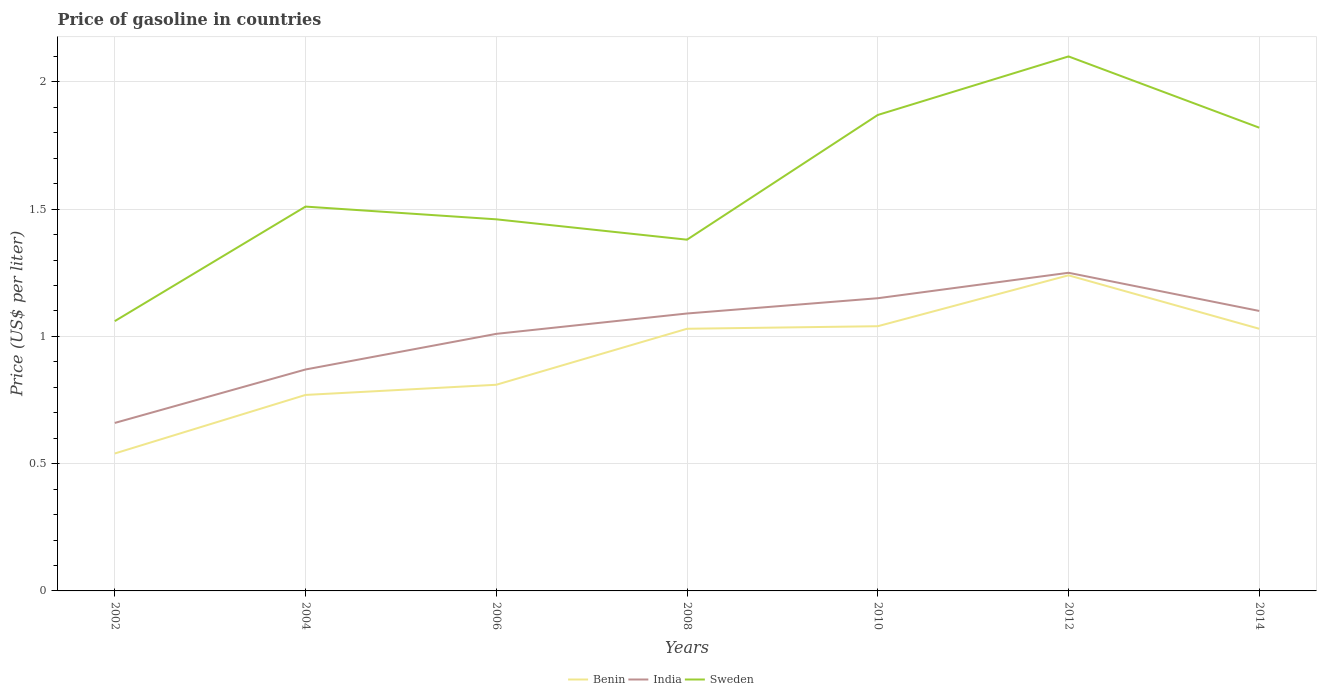How many different coloured lines are there?
Your response must be concise. 3. Is the number of lines equal to the number of legend labels?
Your answer should be very brief. Yes. Across all years, what is the maximum price of gasoline in Sweden?
Your answer should be compact. 1.06. What is the total price of gasoline in India in the graph?
Offer a very short reply. -0.38. What is the difference between the highest and the lowest price of gasoline in Sweden?
Make the answer very short. 3. How many lines are there?
Make the answer very short. 3. How many years are there in the graph?
Keep it short and to the point. 7. What is the difference between two consecutive major ticks on the Y-axis?
Ensure brevity in your answer.  0.5. Does the graph contain any zero values?
Keep it short and to the point. No. Where does the legend appear in the graph?
Your answer should be compact. Bottom center. How many legend labels are there?
Give a very brief answer. 3. How are the legend labels stacked?
Give a very brief answer. Horizontal. What is the title of the graph?
Your answer should be compact. Price of gasoline in countries. Does "Guinea" appear as one of the legend labels in the graph?
Give a very brief answer. No. What is the label or title of the X-axis?
Ensure brevity in your answer.  Years. What is the label or title of the Y-axis?
Your answer should be compact. Price (US$ per liter). What is the Price (US$ per liter) of Benin in 2002?
Offer a terse response. 0.54. What is the Price (US$ per liter) in India in 2002?
Make the answer very short. 0.66. What is the Price (US$ per liter) in Sweden in 2002?
Make the answer very short. 1.06. What is the Price (US$ per liter) of Benin in 2004?
Provide a short and direct response. 0.77. What is the Price (US$ per liter) in India in 2004?
Offer a very short reply. 0.87. What is the Price (US$ per liter) in Sweden in 2004?
Keep it short and to the point. 1.51. What is the Price (US$ per liter) of Benin in 2006?
Make the answer very short. 0.81. What is the Price (US$ per liter) of Sweden in 2006?
Keep it short and to the point. 1.46. What is the Price (US$ per liter) of India in 2008?
Keep it short and to the point. 1.09. What is the Price (US$ per liter) of Sweden in 2008?
Keep it short and to the point. 1.38. What is the Price (US$ per liter) in India in 2010?
Your response must be concise. 1.15. What is the Price (US$ per liter) in Sweden in 2010?
Keep it short and to the point. 1.87. What is the Price (US$ per liter) in Benin in 2012?
Your answer should be very brief. 1.24. What is the Price (US$ per liter) in India in 2012?
Make the answer very short. 1.25. What is the Price (US$ per liter) in India in 2014?
Give a very brief answer. 1.1. What is the Price (US$ per liter) in Sweden in 2014?
Give a very brief answer. 1.82. Across all years, what is the maximum Price (US$ per liter) in Benin?
Keep it short and to the point. 1.24. Across all years, what is the maximum Price (US$ per liter) in Sweden?
Provide a short and direct response. 2.1. Across all years, what is the minimum Price (US$ per liter) of Benin?
Keep it short and to the point. 0.54. Across all years, what is the minimum Price (US$ per liter) in India?
Keep it short and to the point. 0.66. Across all years, what is the minimum Price (US$ per liter) of Sweden?
Offer a terse response. 1.06. What is the total Price (US$ per liter) in Benin in the graph?
Your response must be concise. 6.46. What is the total Price (US$ per liter) of India in the graph?
Offer a very short reply. 7.13. What is the total Price (US$ per liter) in Sweden in the graph?
Your response must be concise. 11.2. What is the difference between the Price (US$ per liter) of Benin in 2002 and that in 2004?
Provide a succinct answer. -0.23. What is the difference between the Price (US$ per liter) of India in 2002 and that in 2004?
Your answer should be very brief. -0.21. What is the difference between the Price (US$ per liter) of Sweden in 2002 and that in 2004?
Your answer should be very brief. -0.45. What is the difference between the Price (US$ per liter) of Benin in 2002 and that in 2006?
Your answer should be very brief. -0.27. What is the difference between the Price (US$ per liter) in India in 2002 and that in 2006?
Give a very brief answer. -0.35. What is the difference between the Price (US$ per liter) in Benin in 2002 and that in 2008?
Provide a short and direct response. -0.49. What is the difference between the Price (US$ per liter) in India in 2002 and that in 2008?
Provide a succinct answer. -0.43. What is the difference between the Price (US$ per liter) in Sweden in 2002 and that in 2008?
Your answer should be very brief. -0.32. What is the difference between the Price (US$ per liter) in India in 2002 and that in 2010?
Offer a very short reply. -0.49. What is the difference between the Price (US$ per liter) in Sweden in 2002 and that in 2010?
Your answer should be compact. -0.81. What is the difference between the Price (US$ per liter) in Benin in 2002 and that in 2012?
Provide a short and direct response. -0.7. What is the difference between the Price (US$ per liter) in India in 2002 and that in 2012?
Make the answer very short. -0.59. What is the difference between the Price (US$ per liter) in Sweden in 2002 and that in 2012?
Provide a succinct answer. -1.04. What is the difference between the Price (US$ per liter) in Benin in 2002 and that in 2014?
Keep it short and to the point. -0.49. What is the difference between the Price (US$ per liter) of India in 2002 and that in 2014?
Your response must be concise. -0.44. What is the difference between the Price (US$ per liter) of Sweden in 2002 and that in 2014?
Ensure brevity in your answer.  -0.76. What is the difference between the Price (US$ per liter) of Benin in 2004 and that in 2006?
Keep it short and to the point. -0.04. What is the difference between the Price (US$ per liter) of India in 2004 and that in 2006?
Offer a very short reply. -0.14. What is the difference between the Price (US$ per liter) in Sweden in 2004 and that in 2006?
Keep it short and to the point. 0.05. What is the difference between the Price (US$ per liter) of Benin in 2004 and that in 2008?
Offer a terse response. -0.26. What is the difference between the Price (US$ per liter) of India in 2004 and that in 2008?
Provide a short and direct response. -0.22. What is the difference between the Price (US$ per liter) of Sweden in 2004 and that in 2008?
Your response must be concise. 0.13. What is the difference between the Price (US$ per liter) in Benin in 2004 and that in 2010?
Make the answer very short. -0.27. What is the difference between the Price (US$ per liter) in India in 2004 and that in 2010?
Your answer should be very brief. -0.28. What is the difference between the Price (US$ per liter) in Sweden in 2004 and that in 2010?
Provide a short and direct response. -0.36. What is the difference between the Price (US$ per liter) of Benin in 2004 and that in 2012?
Make the answer very short. -0.47. What is the difference between the Price (US$ per liter) of India in 2004 and that in 2012?
Offer a very short reply. -0.38. What is the difference between the Price (US$ per liter) of Sweden in 2004 and that in 2012?
Your answer should be compact. -0.59. What is the difference between the Price (US$ per liter) of Benin in 2004 and that in 2014?
Offer a terse response. -0.26. What is the difference between the Price (US$ per liter) in India in 2004 and that in 2014?
Keep it short and to the point. -0.23. What is the difference between the Price (US$ per liter) in Sweden in 2004 and that in 2014?
Your answer should be compact. -0.31. What is the difference between the Price (US$ per liter) in Benin in 2006 and that in 2008?
Provide a succinct answer. -0.22. What is the difference between the Price (US$ per liter) in India in 2006 and that in 2008?
Provide a succinct answer. -0.08. What is the difference between the Price (US$ per liter) in Sweden in 2006 and that in 2008?
Your answer should be compact. 0.08. What is the difference between the Price (US$ per liter) in Benin in 2006 and that in 2010?
Offer a very short reply. -0.23. What is the difference between the Price (US$ per liter) of India in 2006 and that in 2010?
Provide a short and direct response. -0.14. What is the difference between the Price (US$ per liter) in Sweden in 2006 and that in 2010?
Give a very brief answer. -0.41. What is the difference between the Price (US$ per liter) in Benin in 2006 and that in 2012?
Ensure brevity in your answer.  -0.43. What is the difference between the Price (US$ per liter) of India in 2006 and that in 2012?
Your answer should be compact. -0.24. What is the difference between the Price (US$ per liter) in Sweden in 2006 and that in 2012?
Offer a terse response. -0.64. What is the difference between the Price (US$ per liter) in Benin in 2006 and that in 2014?
Your answer should be very brief. -0.22. What is the difference between the Price (US$ per liter) in India in 2006 and that in 2014?
Offer a terse response. -0.09. What is the difference between the Price (US$ per liter) of Sweden in 2006 and that in 2014?
Your response must be concise. -0.36. What is the difference between the Price (US$ per liter) in Benin in 2008 and that in 2010?
Make the answer very short. -0.01. What is the difference between the Price (US$ per liter) of India in 2008 and that in 2010?
Your response must be concise. -0.06. What is the difference between the Price (US$ per liter) of Sweden in 2008 and that in 2010?
Make the answer very short. -0.49. What is the difference between the Price (US$ per liter) in Benin in 2008 and that in 2012?
Ensure brevity in your answer.  -0.21. What is the difference between the Price (US$ per liter) of India in 2008 and that in 2012?
Provide a short and direct response. -0.16. What is the difference between the Price (US$ per liter) in Sweden in 2008 and that in 2012?
Offer a terse response. -0.72. What is the difference between the Price (US$ per liter) of Benin in 2008 and that in 2014?
Offer a very short reply. 0. What is the difference between the Price (US$ per liter) of India in 2008 and that in 2014?
Offer a terse response. -0.01. What is the difference between the Price (US$ per liter) of Sweden in 2008 and that in 2014?
Provide a succinct answer. -0.44. What is the difference between the Price (US$ per liter) of Benin in 2010 and that in 2012?
Provide a succinct answer. -0.2. What is the difference between the Price (US$ per liter) of India in 2010 and that in 2012?
Make the answer very short. -0.1. What is the difference between the Price (US$ per liter) in Sweden in 2010 and that in 2012?
Keep it short and to the point. -0.23. What is the difference between the Price (US$ per liter) of Benin in 2010 and that in 2014?
Offer a very short reply. 0.01. What is the difference between the Price (US$ per liter) in India in 2010 and that in 2014?
Ensure brevity in your answer.  0.05. What is the difference between the Price (US$ per liter) in Sweden in 2010 and that in 2014?
Provide a succinct answer. 0.05. What is the difference between the Price (US$ per liter) of Benin in 2012 and that in 2014?
Your answer should be compact. 0.21. What is the difference between the Price (US$ per liter) of Sweden in 2012 and that in 2014?
Provide a short and direct response. 0.28. What is the difference between the Price (US$ per liter) of Benin in 2002 and the Price (US$ per liter) of India in 2004?
Ensure brevity in your answer.  -0.33. What is the difference between the Price (US$ per liter) in Benin in 2002 and the Price (US$ per liter) in Sweden in 2004?
Ensure brevity in your answer.  -0.97. What is the difference between the Price (US$ per liter) in India in 2002 and the Price (US$ per liter) in Sweden in 2004?
Your answer should be very brief. -0.85. What is the difference between the Price (US$ per liter) of Benin in 2002 and the Price (US$ per liter) of India in 2006?
Make the answer very short. -0.47. What is the difference between the Price (US$ per liter) in Benin in 2002 and the Price (US$ per liter) in Sweden in 2006?
Offer a terse response. -0.92. What is the difference between the Price (US$ per liter) of Benin in 2002 and the Price (US$ per liter) of India in 2008?
Offer a very short reply. -0.55. What is the difference between the Price (US$ per liter) in Benin in 2002 and the Price (US$ per liter) in Sweden in 2008?
Provide a succinct answer. -0.84. What is the difference between the Price (US$ per liter) in India in 2002 and the Price (US$ per liter) in Sweden in 2008?
Your answer should be compact. -0.72. What is the difference between the Price (US$ per liter) in Benin in 2002 and the Price (US$ per liter) in India in 2010?
Your answer should be compact. -0.61. What is the difference between the Price (US$ per liter) of Benin in 2002 and the Price (US$ per liter) of Sweden in 2010?
Offer a very short reply. -1.33. What is the difference between the Price (US$ per liter) of India in 2002 and the Price (US$ per liter) of Sweden in 2010?
Your response must be concise. -1.21. What is the difference between the Price (US$ per liter) of Benin in 2002 and the Price (US$ per liter) of India in 2012?
Provide a succinct answer. -0.71. What is the difference between the Price (US$ per liter) in Benin in 2002 and the Price (US$ per liter) in Sweden in 2012?
Keep it short and to the point. -1.56. What is the difference between the Price (US$ per liter) in India in 2002 and the Price (US$ per liter) in Sweden in 2012?
Offer a terse response. -1.44. What is the difference between the Price (US$ per liter) of Benin in 2002 and the Price (US$ per liter) of India in 2014?
Give a very brief answer. -0.56. What is the difference between the Price (US$ per liter) of Benin in 2002 and the Price (US$ per liter) of Sweden in 2014?
Offer a very short reply. -1.28. What is the difference between the Price (US$ per liter) of India in 2002 and the Price (US$ per liter) of Sweden in 2014?
Keep it short and to the point. -1.16. What is the difference between the Price (US$ per liter) in Benin in 2004 and the Price (US$ per liter) in India in 2006?
Offer a very short reply. -0.24. What is the difference between the Price (US$ per liter) in Benin in 2004 and the Price (US$ per liter) in Sweden in 2006?
Ensure brevity in your answer.  -0.69. What is the difference between the Price (US$ per liter) in India in 2004 and the Price (US$ per liter) in Sweden in 2006?
Make the answer very short. -0.59. What is the difference between the Price (US$ per liter) of Benin in 2004 and the Price (US$ per liter) of India in 2008?
Your answer should be compact. -0.32. What is the difference between the Price (US$ per liter) in Benin in 2004 and the Price (US$ per liter) in Sweden in 2008?
Offer a terse response. -0.61. What is the difference between the Price (US$ per liter) of India in 2004 and the Price (US$ per liter) of Sweden in 2008?
Offer a terse response. -0.51. What is the difference between the Price (US$ per liter) of Benin in 2004 and the Price (US$ per liter) of India in 2010?
Provide a succinct answer. -0.38. What is the difference between the Price (US$ per liter) in Benin in 2004 and the Price (US$ per liter) in Sweden in 2010?
Your answer should be very brief. -1.1. What is the difference between the Price (US$ per liter) in Benin in 2004 and the Price (US$ per liter) in India in 2012?
Ensure brevity in your answer.  -0.48. What is the difference between the Price (US$ per liter) in Benin in 2004 and the Price (US$ per liter) in Sweden in 2012?
Provide a short and direct response. -1.33. What is the difference between the Price (US$ per liter) in India in 2004 and the Price (US$ per liter) in Sweden in 2012?
Provide a short and direct response. -1.23. What is the difference between the Price (US$ per liter) in Benin in 2004 and the Price (US$ per liter) in India in 2014?
Offer a terse response. -0.33. What is the difference between the Price (US$ per liter) of Benin in 2004 and the Price (US$ per liter) of Sweden in 2014?
Provide a succinct answer. -1.05. What is the difference between the Price (US$ per liter) of India in 2004 and the Price (US$ per liter) of Sweden in 2014?
Your response must be concise. -0.95. What is the difference between the Price (US$ per liter) of Benin in 2006 and the Price (US$ per liter) of India in 2008?
Keep it short and to the point. -0.28. What is the difference between the Price (US$ per liter) in Benin in 2006 and the Price (US$ per liter) in Sweden in 2008?
Provide a short and direct response. -0.57. What is the difference between the Price (US$ per liter) in India in 2006 and the Price (US$ per liter) in Sweden in 2008?
Your response must be concise. -0.37. What is the difference between the Price (US$ per liter) of Benin in 2006 and the Price (US$ per liter) of India in 2010?
Ensure brevity in your answer.  -0.34. What is the difference between the Price (US$ per liter) of Benin in 2006 and the Price (US$ per liter) of Sweden in 2010?
Provide a short and direct response. -1.06. What is the difference between the Price (US$ per liter) in India in 2006 and the Price (US$ per liter) in Sweden in 2010?
Ensure brevity in your answer.  -0.86. What is the difference between the Price (US$ per liter) in Benin in 2006 and the Price (US$ per liter) in India in 2012?
Your response must be concise. -0.44. What is the difference between the Price (US$ per liter) in Benin in 2006 and the Price (US$ per liter) in Sweden in 2012?
Provide a short and direct response. -1.29. What is the difference between the Price (US$ per liter) in India in 2006 and the Price (US$ per liter) in Sweden in 2012?
Keep it short and to the point. -1.09. What is the difference between the Price (US$ per liter) in Benin in 2006 and the Price (US$ per liter) in India in 2014?
Provide a short and direct response. -0.29. What is the difference between the Price (US$ per liter) in Benin in 2006 and the Price (US$ per liter) in Sweden in 2014?
Your answer should be compact. -1.01. What is the difference between the Price (US$ per liter) of India in 2006 and the Price (US$ per liter) of Sweden in 2014?
Keep it short and to the point. -0.81. What is the difference between the Price (US$ per liter) of Benin in 2008 and the Price (US$ per liter) of India in 2010?
Your response must be concise. -0.12. What is the difference between the Price (US$ per liter) of Benin in 2008 and the Price (US$ per liter) of Sweden in 2010?
Your answer should be compact. -0.84. What is the difference between the Price (US$ per liter) in India in 2008 and the Price (US$ per liter) in Sweden in 2010?
Make the answer very short. -0.78. What is the difference between the Price (US$ per liter) of Benin in 2008 and the Price (US$ per liter) of India in 2012?
Ensure brevity in your answer.  -0.22. What is the difference between the Price (US$ per liter) in Benin in 2008 and the Price (US$ per liter) in Sweden in 2012?
Give a very brief answer. -1.07. What is the difference between the Price (US$ per liter) of India in 2008 and the Price (US$ per liter) of Sweden in 2012?
Keep it short and to the point. -1.01. What is the difference between the Price (US$ per liter) of Benin in 2008 and the Price (US$ per liter) of India in 2014?
Provide a short and direct response. -0.07. What is the difference between the Price (US$ per liter) of Benin in 2008 and the Price (US$ per liter) of Sweden in 2014?
Give a very brief answer. -0.79. What is the difference between the Price (US$ per liter) in India in 2008 and the Price (US$ per liter) in Sweden in 2014?
Give a very brief answer. -0.73. What is the difference between the Price (US$ per liter) in Benin in 2010 and the Price (US$ per liter) in India in 2012?
Your response must be concise. -0.21. What is the difference between the Price (US$ per liter) of Benin in 2010 and the Price (US$ per liter) of Sweden in 2012?
Make the answer very short. -1.06. What is the difference between the Price (US$ per liter) in India in 2010 and the Price (US$ per liter) in Sweden in 2012?
Provide a short and direct response. -0.95. What is the difference between the Price (US$ per liter) of Benin in 2010 and the Price (US$ per liter) of India in 2014?
Your answer should be very brief. -0.06. What is the difference between the Price (US$ per liter) of Benin in 2010 and the Price (US$ per liter) of Sweden in 2014?
Ensure brevity in your answer.  -0.78. What is the difference between the Price (US$ per liter) in India in 2010 and the Price (US$ per liter) in Sweden in 2014?
Provide a short and direct response. -0.67. What is the difference between the Price (US$ per liter) in Benin in 2012 and the Price (US$ per liter) in India in 2014?
Make the answer very short. 0.14. What is the difference between the Price (US$ per liter) in Benin in 2012 and the Price (US$ per liter) in Sweden in 2014?
Your answer should be very brief. -0.58. What is the difference between the Price (US$ per liter) of India in 2012 and the Price (US$ per liter) of Sweden in 2014?
Provide a succinct answer. -0.57. What is the average Price (US$ per liter) of Benin per year?
Provide a succinct answer. 0.92. What is the average Price (US$ per liter) of India per year?
Keep it short and to the point. 1.02. In the year 2002, what is the difference between the Price (US$ per liter) in Benin and Price (US$ per liter) in India?
Provide a short and direct response. -0.12. In the year 2002, what is the difference between the Price (US$ per liter) in Benin and Price (US$ per liter) in Sweden?
Keep it short and to the point. -0.52. In the year 2004, what is the difference between the Price (US$ per liter) in Benin and Price (US$ per liter) in India?
Keep it short and to the point. -0.1. In the year 2004, what is the difference between the Price (US$ per liter) in Benin and Price (US$ per liter) in Sweden?
Provide a short and direct response. -0.74. In the year 2004, what is the difference between the Price (US$ per liter) of India and Price (US$ per liter) of Sweden?
Your answer should be compact. -0.64. In the year 2006, what is the difference between the Price (US$ per liter) in Benin and Price (US$ per liter) in Sweden?
Your answer should be compact. -0.65. In the year 2006, what is the difference between the Price (US$ per liter) of India and Price (US$ per liter) of Sweden?
Your answer should be very brief. -0.45. In the year 2008, what is the difference between the Price (US$ per liter) of Benin and Price (US$ per liter) of India?
Make the answer very short. -0.06. In the year 2008, what is the difference between the Price (US$ per liter) of Benin and Price (US$ per liter) of Sweden?
Offer a terse response. -0.35. In the year 2008, what is the difference between the Price (US$ per liter) in India and Price (US$ per liter) in Sweden?
Offer a very short reply. -0.29. In the year 2010, what is the difference between the Price (US$ per liter) in Benin and Price (US$ per liter) in India?
Your response must be concise. -0.11. In the year 2010, what is the difference between the Price (US$ per liter) of Benin and Price (US$ per liter) of Sweden?
Make the answer very short. -0.83. In the year 2010, what is the difference between the Price (US$ per liter) in India and Price (US$ per liter) in Sweden?
Your response must be concise. -0.72. In the year 2012, what is the difference between the Price (US$ per liter) in Benin and Price (US$ per liter) in India?
Keep it short and to the point. -0.01. In the year 2012, what is the difference between the Price (US$ per liter) in Benin and Price (US$ per liter) in Sweden?
Your response must be concise. -0.86. In the year 2012, what is the difference between the Price (US$ per liter) in India and Price (US$ per liter) in Sweden?
Provide a short and direct response. -0.85. In the year 2014, what is the difference between the Price (US$ per liter) in Benin and Price (US$ per liter) in India?
Provide a short and direct response. -0.07. In the year 2014, what is the difference between the Price (US$ per liter) in Benin and Price (US$ per liter) in Sweden?
Your response must be concise. -0.79. In the year 2014, what is the difference between the Price (US$ per liter) in India and Price (US$ per liter) in Sweden?
Your answer should be very brief. -0.72. What is the ratio of the Price (US$ per liter) in Benin in 2002 to that in 2004?
Offer a very short reply. 0.7. What is the ratio of the Price (US$ per liter) of India in 2002 to that in 2004?
Provide a succinct answer. 0.76. What is the ratio of the Price (US$ per liter) in Sweden in 2002 to that in 2004?
Make the answer very short. 0.7. What is the ratio of the Price (US$ per liter) of India in 2002 to that in 2006?
Give a very brief answer. 0.65. What is the ratio of the Price (US$ per liter) in Sweden in 2002 to that in 2006?
Provide a short and direct response. 0.73. What is the ratio of the Price (US$ per liter) in Benin in 2002 to that in 2008?
Give a very brief answer. 0.52. What is the ratio of the Price (US$ per liter) of India in 2002 to that in 2008?
Offer a very short reply. 0.61. What is the ratio of the Price (US$ per liter) of Sweden in 2002 to that in 2008?
Provide a short and direct response. 0.77. What is the ratio of the Price (US$ per liter) of Benin in 2002 to that in 2010?
Give a very brief answer. 0.52. What is the ratio of the Price (US$ per liter) of India in 2002 to that in 2010?
Provide a succinct answer. 0.57. What is the ratio of the Price (US$ per liter) in Sweden in 2002 to that in 2010?
Your answer should be compact. 0.57. What is the ratio of the Price (US$ per liter) of Benin in 2002 to that in 2012?
Your response must be concise. 0.44. What is the ratio of the Price (US$ per liter) in India in 2002 to that in 2012?
Ensure brevity in your answer.  0.53. What is the ratio of the Price (US$ per liter) in Sweden in 2002 to that in 2012?
Ensure brevity in your answer.  0.5. What is the ratio of the Price (US$ per liter) of Benin in 2002 to that in 2014?
Provide a short and direct response. 0.52. What is the ratio of the Price (US$ per liter) of India in 2002 to that in 2014?
Offer a terse response. 0.6. What is the ratio of the Price (US$ per liter) of Sweden in 2002 to that in 2014?
Provide a succinct answer. 0.58. What is the ratio of the Price (US$ per liter) of Benin in 2004 to that in 2006?
Offer a terse response. 0.95. What is the ratio of the Price (US$ per liter) of India in 2004 to that in 2006?
Provide a short and direct response. 0.86. What is the ratio of the Price (US$ per liter) of Sweden in 2004 to that in 2006?
Give a very brief answer. 1.03. What is the ratio of the Price (US$ per liter) in Benin in 2004 to that in 2008?
Your response must be concise. 0.75. What is the ratio of the Price (US$ per liter) in India in 2004 to that in 2008?
Your answer should be very brief. 0.8. What is the ratio of the Price (US$ per liter) in Sweden in 2004 to that in 2008?
Make the answer very short. 1.09. What is the ratio of the Price (US$ per liter) of Benin in 2004 to that in 2010?
Your answer should be compact. 0.74. What is the ratio of the Price (US$ per liter) of India in 2004 to that in 2010?
Your response must be concise. 0.76. What is the ratio of the Price (US$ per liter) of Sweden in 2004 to that in 2010?
Your response must be concise. 0.81. What is the ratio of the Price (US$ per liter) of Benin in 2004 to that in 2012?
Ensure brevity in your answer.  0.62. What is the ratio of the Price (US$ per liter) in India in 2004 to that in 2012?
Offer a terse response. 0.7. What is the ratio of the Price (US$ per liter) in Sweden in 2004 to that in 2012?
Offer a terse response. 0.72. What is the ratio of the Price (US$ per liter) in Benin in 2004 to that in 2014?
Provide a short and direct response. 0.75. What is the ratio of the Price (US$ per liter) in India in 2004 to that in 2014?
Give a very brief answer. 0.79. What is the ratio of the Price (US$ per liter) in Sweden in 2004 to that in 2014?
Provide a short and direct response. 0.83. What is the ratio of the Price (US$ per liter) of Benin in 2006 to that in 2008?
Provide a short and direct response. 0.79. What is the ratio of the Price (US$ per liter) in India in 2006 to that in 2008?
Make the answer very short. 0.93. What is the ratio of the Price (US$ per liter) in Sweden in 2006 to that in 2008?
Ensure brevity in your answer.  1.06. What is the ratio of the Price (US$ per liter) in Benin in 2006 to that in 2010?
Provide a short and direct response. 0.78. What is the ratio of the Price (US$ per liter) of India in 2006 to that in 2010?
Make the answer very short. 0.88. What is the ratio of the Price (US$ per liter) in Sweden in 2006 to that in 2010?
Provide a succinct answer. 0.78. What is the ratio of the Price (US$ per liter) in Benin in 2006 to that in 2012?
Ensure brevity in your answer.  0.65. What is the ratio of the Price (US$ per liter) of India in 2006 to that in 2012?
Your response must be concise. 0.81. What is the ratio of the Price (US$ per liter) in Sweden in 2006 to that in 2012?
Ensure brevity in your answer.  0.7. What is the ratio of the Price (US$ per liter) of Benin in 2006 to that in 2014?
Your answer should be very brief. 0.79. What is the ratio of the Price (US$ per liter) in India in 2006 to that in 2014?
Keep it short and to the point. 0.92. What is the ratio of the Price (US$ per liter) of Sweden in 2006 to that in 2014?
Keep it short and to the point. 0.8. What is the ratio of the Price (US$ per liter) in India in 2008 to that in 2010?
Provide a succinct answer. 0.95. What is the ratio of the Price (US$ per liter) of Sweden in 2008 to that in 2010?
Your answer should be very brief. 0.74. What is the ratio of the Price (US$ per liter) of Benin in 2008 to that in 2012?
Keep it short and to the point. 0.83. What is the ratio of the Price (US$ per liter) in India in 2008 to that in 2012?
Ensure brevity in your answer.  0.87. What is the ratio of the Price (US$ per liter) in Sweden in 2008 to that in 2012?
Ensure brevity in your answer.  0.66. What is the ratio of the Price (US$ per liter) of India in 2008 to that in 2014?
Keep it short and to the point. 0.99. What is the ratio of the Price (US$ per liter) of Sweden in 2008 to that in 2014?
Provide a succinct answer. 0.76. What is the ratio of the Price (US$ per liter) in Benin in 2010 to that in 2012?
Your answer should be compact. 0.84. What is the ratio of the Price (US$ per liter) in Sweden in 2010 to that in 2012?
Provide a succinct answer. 0.89. What is the ratio of the Price (US$ per liter) in Benin in 2010 to that in 2014?
Your answer should be very brief. 1.01. What is the ratio of the Price (US$ per liter) of India in 2010 to that in 2014?
Offer a terse response. 1.05. What is the ratio of the Price (US$ per liter) in Sweden in 2010 to that in 2014?
Offer a very short reply. 1.03. What is the ratio of the Price (US$ per liter) in Benin in 2012 to that in 2014?
Give a very brief answer. 1.2. What is the ratio of the Price (US$ per liter) in India in 2012 to that in 2014?
Offer a terse response. 1.14. What is the ratio of the Price (US$ per liter) in Sweden in 2012 to that in 2014?
Provide a succinct answer. 1.15. What is the difference between the highest and the second highest Price (US$ per liter) in Benin?
Provide a short and direct response. 0.2. What is the difference between the highest and the second highest Price (US$ per liter) in India?
Your answer should be very brief. 0.1. What is the difference between the highest and the second highest Price (US$ per liter) of Sweden?
Offer a very short reply. 0.23. What is the difference between the highest and the lowest Price (US$ per liter) of Benin?
Provide a succinct answer. 0.7. What is the difference between the highest and the lowest Price (US$ per liter) of India?
Give a very brief answer. 0.59. What is the difference between the highest and the lowest Price (US$ per liter) of Sweden?
Ensure brevity in your answer.  1.04. 